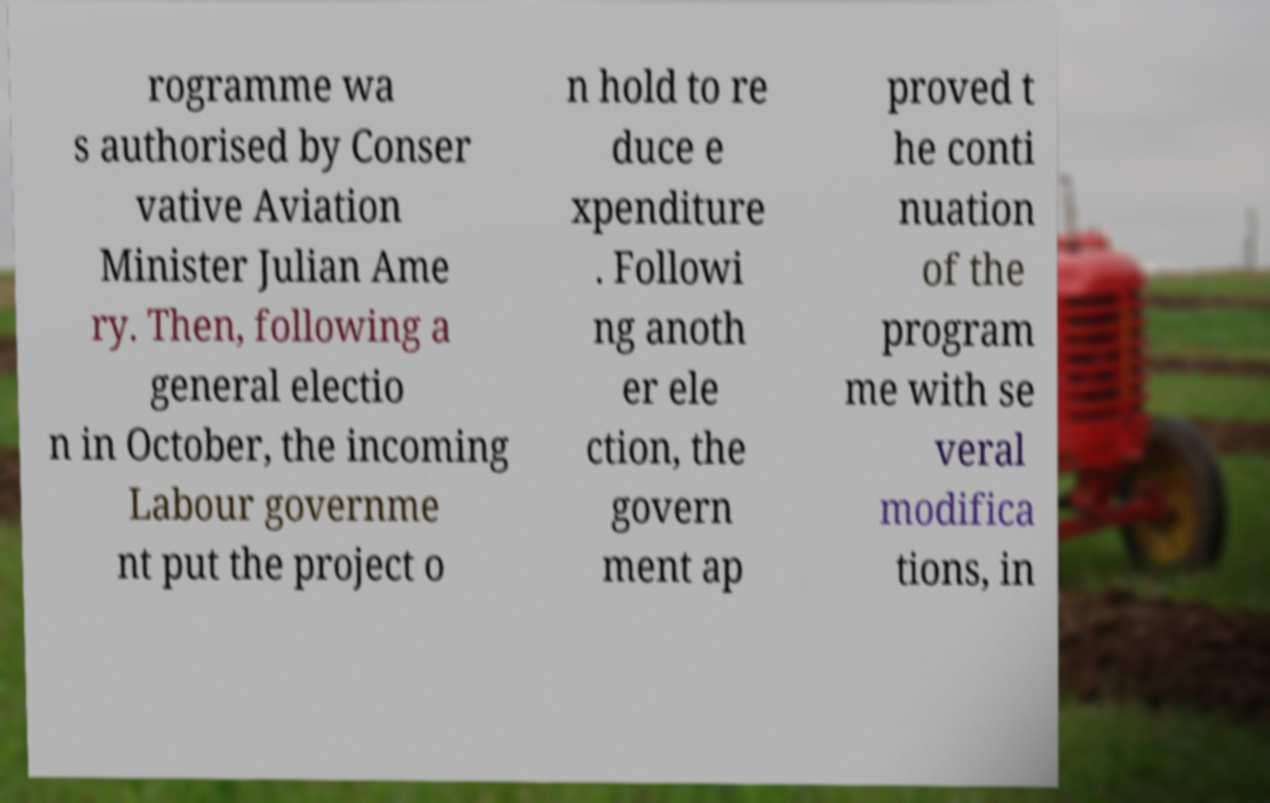I need the written content from this picture converted into text. Can you do that? rogramme wa s authorised by Conser vative Aviation Minister Julian Ame ry. Then, following a general electio n in October, the incoming Labour governme nt put the project o n hold to re duce e xpenditure . Followi ng anoth er ele ction, the govern ment ap proved t he conti nuation of the program me with se veral modifica tions, in 